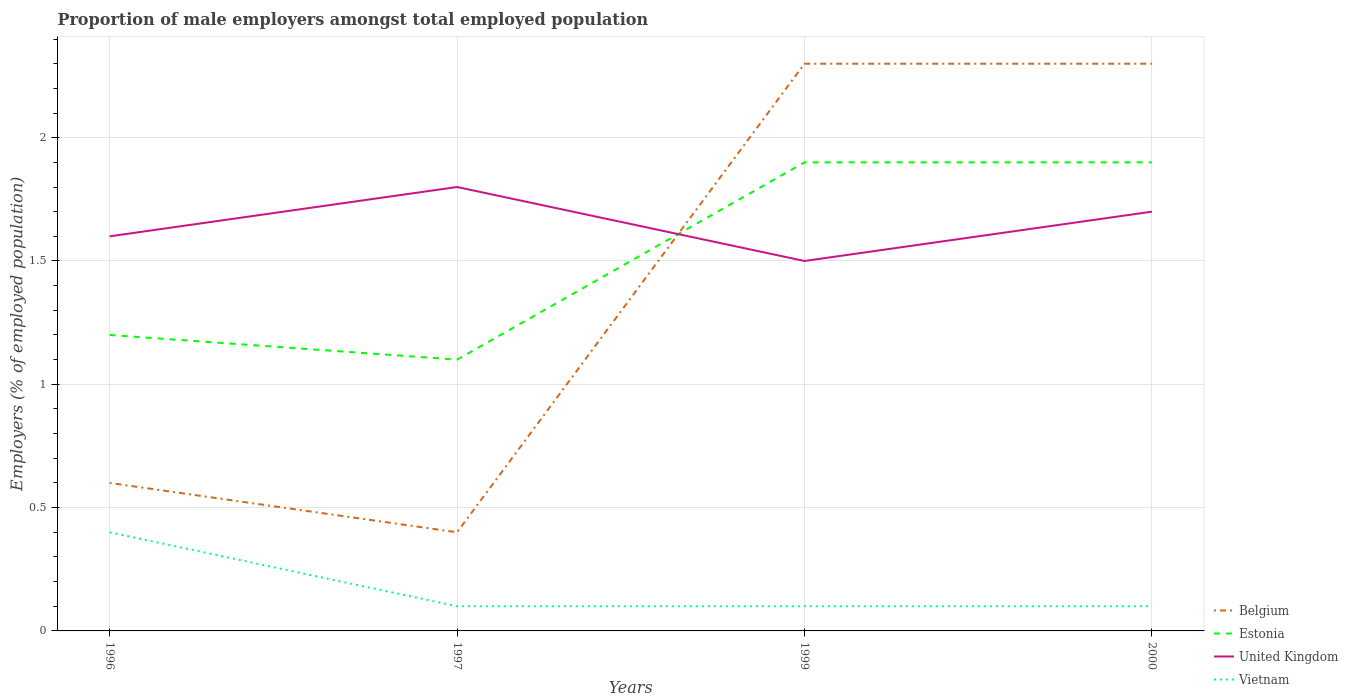How many different coloured lines are there?
Your answer should be compact. 4. Does the line corresponding to Estonia intersect with the line corresponding to Vietnam?
Keep it short and to the point. No. Is the number of lines equal to the number of legend labels?
Offer a very short reply. Yes. Across all years, what is the maximum proportion of male employers in United Kingdom?
Your answer should be compact. 1.5. In which year was the proportion of male employers in Estonia maximum?
Your response must be concise. 1997. What is the total proportion of male employers in United Kingdom in the graph?
Your answer should be very brief. -0.1. What is the difference between the highest and the second highest proportion of male employers in Belgium?
Give a very brief answer. 1.9. What is the difference between the highest and the lowest proportion of male employers in Estonia?
Provide a succinct answer. 2. Is the proportion of male employers in Belgium strictly greater than the proportion of male employers in Vietnam over the years?
Provide a succinct answer. No. How many lines are there?
Provide a short and direct response. 4. How many years are there in the graph?
Provide a succinct answer. 4. What is the difference between two consecutive major ticks on the Y-axis?
Offer a very short reply. 0.5. Are the values on the major ticks of Y-axis written in scientific E-notation?
Provide a succinct answer. No. How many legend labels are there?
Keep it short and to the point. 4. How are the legend labels stacked?
Offer a terse response. Vertical. What is the title of the graph?
Give a very brief answer. Proportion of male employers amongst total employed population. Does "Canada" appear as one of the legend labels in the graph?
Provide a short and direct response. No. What is the label or title of the X-axis?
Give a very brief answer. Years. What is the label or title of the Y-axis?
Give a very brief answer. Employers (% of employed population). What is the Employers (% of employed population) of Belgium in 1996?
Offer a terse response. 0.6. What is the Employers (% of employed population) in Estonia in 1996?
Make the answer very short. 1.2. What is the Employers (% of employed population) in United Kingdom in 1996?
Offer a terse response. 1.6. What is the Employers (% of employed population) of Vietnam in 1996?
Your answer should be very brief. 0.4. What is the Employers (% of employed population) in Belgium in 1997?
Ensure brevity in your answer.  0.4. What is the Employers (% of employed population) of Estonia in 1997?
Provide a succinct answer. 1.1. What is the Employers (% of employed population) of United Kingdom in 1997?
Your answer should be compact. 1.8. What is the Employers (% of employed population) in Vietnam in 1997?
Give a very brief answer. 0.1. What is the Employers (% of employed population) of Belgium in 1999?
Provide a short and direct response. 2.3. What is the Employers (% of employed population) of Estonia in 1999?
Make the answer very short. 1.9. What is the Employers (% of employed population) of Vietnam in 1999?
Make the answer very short. 0.1. What is the Employers (% of employed population) of Belgium in 2000?
Keep it short and to the point. 2.3. What is the Employers (% of employed population) of Estonia in 2000?
Ensure brevity in your answer.  1.9. What is the Employers (% of employed population) of United Kingdom in 2000?
Keep it short and to the point. 1.7. What is the Employers (% of employed population) in Vietnam in 2000?
Offer a very short reply. 0.1. Across all years, what is the maximum Employers (% of employed population) in Belgium?
Ensure brevity in your answer.  2.3. Across all years, what is the maximum Employers (% of employed population) in Estonia?
Your answer should be compact. 1.9. Across all years, what is the maximum Employers (% of employed population) in United Kingdom?
Provide a short and direct response. 1.8. Across all years, what is the maximum Employers (% of employed population) of Vietnam?
Your answer should be very brief. 0.4. Across all years, what is the minimum Employers (% of employed population) of Belgium?
Give a very brief answer. 0.4. Across all years, what is the minimum Employers (% of employed population) in Estonia?
Your response must be concise. 1.1. Across all years, what is the minimum Employers (% of employed population) of Vietnam?
Keep it short and to the point. 0.1. What is the total Employers (% of employed population) in Belgium in the graph?
Provide a short and direct response. 5.6. What is the total Employers (% of employed population) of Estonia in the graph?
Provide a succinct answer. 6.1. What is the total Employers (% of employed population) of Vietnam in the graph?
Keep it short and to the point. 0.7. What is the difference between the Employers (% of employed population) in Belgium in 1996 and that in 1997?
Provide a short and direct response. 0.2. What is the difference between the Employers (% of employed population) in Estonia in 1996 and that in 1997?
Give a very brief answer. 0.1. What is the difference between the Employers (% of employed population) of United Kingdom in 1996 and that in 1997?
Ensure brevity in your answer.  -0.2. What is the difference between the Employers (% of employed population) in Belgium in 1996 and that in 1999?
Make the answer very short. -1.7. What is the difference between the Employers (% of employed population) in United Kingdom in 1996 and that in 1999?
Your answer should be very brief. 0.1. What is the difference between the Employers (% of employed population) of Belgium in 1996 and that in 2000?
Provide a succinct answer. -1.7. What is the difference between the Employers (% of employed population) in United Kingdom in 1996 and that in 2000?
Your answer should be compact. -0.1. What is the difference between the Employers (% of employed population) of Belgium in 1997 and that in 2000?
Ensure brevity in your answer.  -1.9. What is the difference between the Employers (% of employed population) of United Kingdom in 1997 and that in 2000?
Your answer should be very brief. 0.1. What is the difference between the Employers (% of employed population) in Belgium in 1999 and that in 2000?
Provide a short and direct response. 0. What is the difference between the Employers (% of employed population) in United Kingdom in 1999 and that in 2000?
Make the answer very short. -0.2. What is the difference between the Employers (% of employed population) of Vietnam in 1999 and that in 2000?
Keep it short and to the point. 0. What is the difference between the Employers (% of employed population) in Belgium in 1996 and the Employers (% of employed population) in United Kingdom in 1997?
Offer a terse response. -1.2. What is the difference between the Employers (% of employed population) in Belgium in 1996 and the Employers (% of employed population) in Vietnam in 1997?
Your answer should be compact. 0.5. What is the difference between the Employers (% of employed population) in United Kingdom in 1996 and the Employers (% of employed population) in Vietnam in 1997?
Make the answer very short. 1.5. What is the difference between the Employers (% of employed population) of Belgium in 1996 and the Employers (% of employed population) of United Kingdom in 1999?
Ensure brevity in your answer.  -0.9. What is the difference between the Employers (% of employed population) in Belgium in 1996 and the Employers (% of employed population) in Vietnam in 2000?
Provide a short and direct response. 0.5. What is the difference between the Employers (% of employed population) in Estonia in 1996 and the Employers (% of employed population) in United Kingdom in 2000?
Provide a short and direct response. -0.5. What is the difference between the Employers (% of employed population) of Estonia in 1996 and the Employers (% of employed population) of Vietnam in 2000?
Provide a succinct answer. 1.1. What is the difference between the Employers (% of employed population) in Belgium in 1997 and the Employers (% of employed population) in Estonia in 1999?
Provide a succinct answer. -1.5. What is the difference between the Employers (% of employed population) of Belgium in 1997 and the Employers (% of employed population) of United Kingdom in 1999?
Your answer should be compact. -1.1. What is the difference between the Employers (% of employed population) of Estonia in 1997 and the Employers (% of employed population) of United Kingdom in 1999?
Keep it short and to the point. -0.4. What is the difference between the Employers (% of employed population) in Belgium in 1997 and the Employers (% of employed population) in Estonia in 2000?
Provide a succinct answer. -1.5. What is the difference between the Employers (% of employed population) of Estonia in 1997 and the Employers (% of employed population) of United Kingdom in 2000?
Ensure brevity in your answer.  -0.6. What is the difference between the Employers (% of employed population) in Estonia in 1997 and the Employers (% of employed population) in Vietnam in 2000?
Make the answer very short. 1. What is the difference between the Employers (% of employed population) of Belgium in 1999 and the Employers (% of employed population) of United Kingdom in 2000?
Your answer should be very brief. 0.6. What is the difference between the Employers (% of employed population) in Belgium in 1999 and the Employers (% of employed population) in Vietnam in 2000?
Offer a terse response. 2.2. What is the difference between the Employers (% of employed population) in Estonia in 1999 and the Employers (% of employed population) in United Kingdom in 2000?
Keep it short and to the point. 0.2. What is the difference between the Employers (% of employed population) in Estonia in 1999 and the Employers (% of employed population) in Vietnam in 2000?
Your response must be concise. 1.8. What is the average Employers (% of employed population) of Belgium per year?
Make the answer very short. 1.4. What is the average Employers (% of employed population) of Estonia per year?
Provide a succinct answer. 1.52. What is the average Employers (% of employed population) in United Kingdom per year?
Make the answer very short. 1.65. What is the average Employers (% of employed population) of Vietnam per year?
Provide a succinct answer. 0.17. In the year 1996, what is the difference between the Employers (% of employed population) of Belgium and Employers (% of employed population) of Estonia?
Give a very brief answer. -0.6. In the year 1996, what is the difference between the Employers (% of employed population) of Belgium and Employers (% of employed population) of United Kingdom?
Make the answer very short. -1. In the year 1996, what is the difference between the Employers (% of employed population) of Estonia and Employers (% of employed population) of United Kingdom?
Your answer should be very brief. -0.4. In the year 1997, what is the difference between the Employers (% of employed population) of Belgium and Employers (% of employed population) of Vietnam?
Your answer should be compact. 0.3. In the year 1997, what is the difference between the Employers (% of employed population) in Estonia and Employers (% of employed population) in United Kingdom?
Your answer should be very brief. -0.7. In the year 1999, what is the difference between the Employers (% of employed population) of United Kingdom and Employers (% of employed population) of Vietnam?
Offer a terse response. 1.4. In the year 2000, what is the difference between the Employers (% of employed population) in Belgium and Employers (% of employed population) in United Kingdom?
Your answer should be very brief. 0.6. In the year 2000, what is the difference between the Employers (% of employed population) in Belgium and Employers (% of employed population) in Vietnam?
Keep it short and to the point. 2.2. In the year 2000, what is the difference between the Employers (% of employed population) in Estonia and Employers (% of employed population) in Vietnam?
Your answer should be compact. 1.8. In the year 2000, what is the difference between the Employers (% of employed population) in United Kingdom and Employers (% of employed population) in Vietnam?
Your response must be concise. 1.6. What is the ratio of the Employers (% of employed population) in Belgium in 1996 to that in 1997?
Offer a very short reply. 1.5. What is the ratio of the Employers (% of employed population) in Estonia in 1996 to that in 1997?
Ensure brevity in your answer.  1.09. What is the ratio of the Employers (% of employed population) in United Kingdom in 1996 to that in 1997?
Offer a very short reply. 0.89. What is the ratio of the Employers (% of employed population) of Belgium in 1996 to that in 1999?
Provide a succinct answer. 0.26. What is the ratio of the Employers (% of employed population) in Estonia in 1996 to that in 1999?
Ensure brevity in your answer.  0.63. What is the ratio of the Employers (% of employed population) of United Kingdom in 1996 to that in 1999?
Ensure brevity in your answer.  1.07. What is the ratio of the Employers (% of employed population) in Vietnam in 1996 to that in 1999?
Offer a very short reply. 4. What is the ratio of the Employers (% of employed population) in Belgium in 1996 to that in 2000?
Offer a terse response. 0.26. What is the ratio of the Employers (% of employed population) of Estonia in 1996 to that in 2000?
Provide a short and direct response. 0.63. What is the ratio of the Employers (% of employed population) in Belgium in 1997 to that in 1999?
Provide a succinct answer. 0.17. What is the ratio of the Employers (% of employed population) in Estonia in 1997 to that in 1999?
Your answer should be compact. 0.58. What is the ratio of the Employers (% of employed population) in United Kingdom in 1997 to that in 1999?
Ensure brevity in your answer.  1.2. What is the ratio of the Employers (% of employed population) of Belgium in 1997 to that in 2000?
Ensure brevity in your answer.  0.17. What is the ratio of the Employers (% of employed population) in Estonia in 1997 to that in 2000?
Offer a very short reply. 0.58. What is the ratio of the Employers (% of employed population) in United Kingdom in 1997 to that in 2000?
Ensure brevity in your answer.  1.06. What is the ratio of the Employers (% of employed population) of Vietnam in 1997 to that in 2000?
Offer a terse response. 1. What is the ratio of the Employers (% of employed population) of Belgium in 1999 to that in 2000?
Your answer should be very brief. 1. What is the ratio of the Employers (% of employed population) in Estonia in 1999 to that in 2000?
Your response must be concise. 1. What is the ratio of the Employers (% of employed population) in United Kingdom in 1999 to that in 2000?
Offer a terse response. 0.88. What is the ratio of the Employers (% of employed population) in Vietnam in 1999 to that in 2000?
Give a very brief answer. 1. What is the difference between the highest and the second highest Employers (% of employed population) of Belgium?
Give a very brief answer. 0. What is the difference between the highest and the second highest Employers (% of employed population) in Estonia?
Give a very brief answer. 0. What is the difference between the highest and the lowest Employers (% of employed population) in Estonia?
Provide a short and direct response. 0.8. What is the difference between the highest and the lowest Employers (% of employed population) in Vietnam?
Your answer should be very brief. 0.3. 